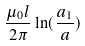Convert formula to latex. <formula><loc_0><loc_0><loc_500><loc_500>\frac { \mu _ { 0 } l } { 2 \pi } \ln ( \frac { a _ { 1 } } { a } )</formula> 